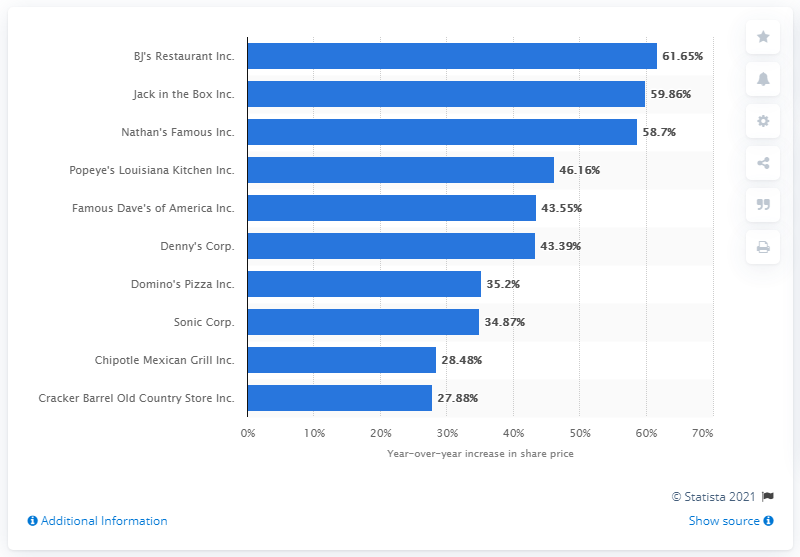Point out several critical features in this image. In 2014, BJ's Restaurant Inc. was the best performing restaurant company. 